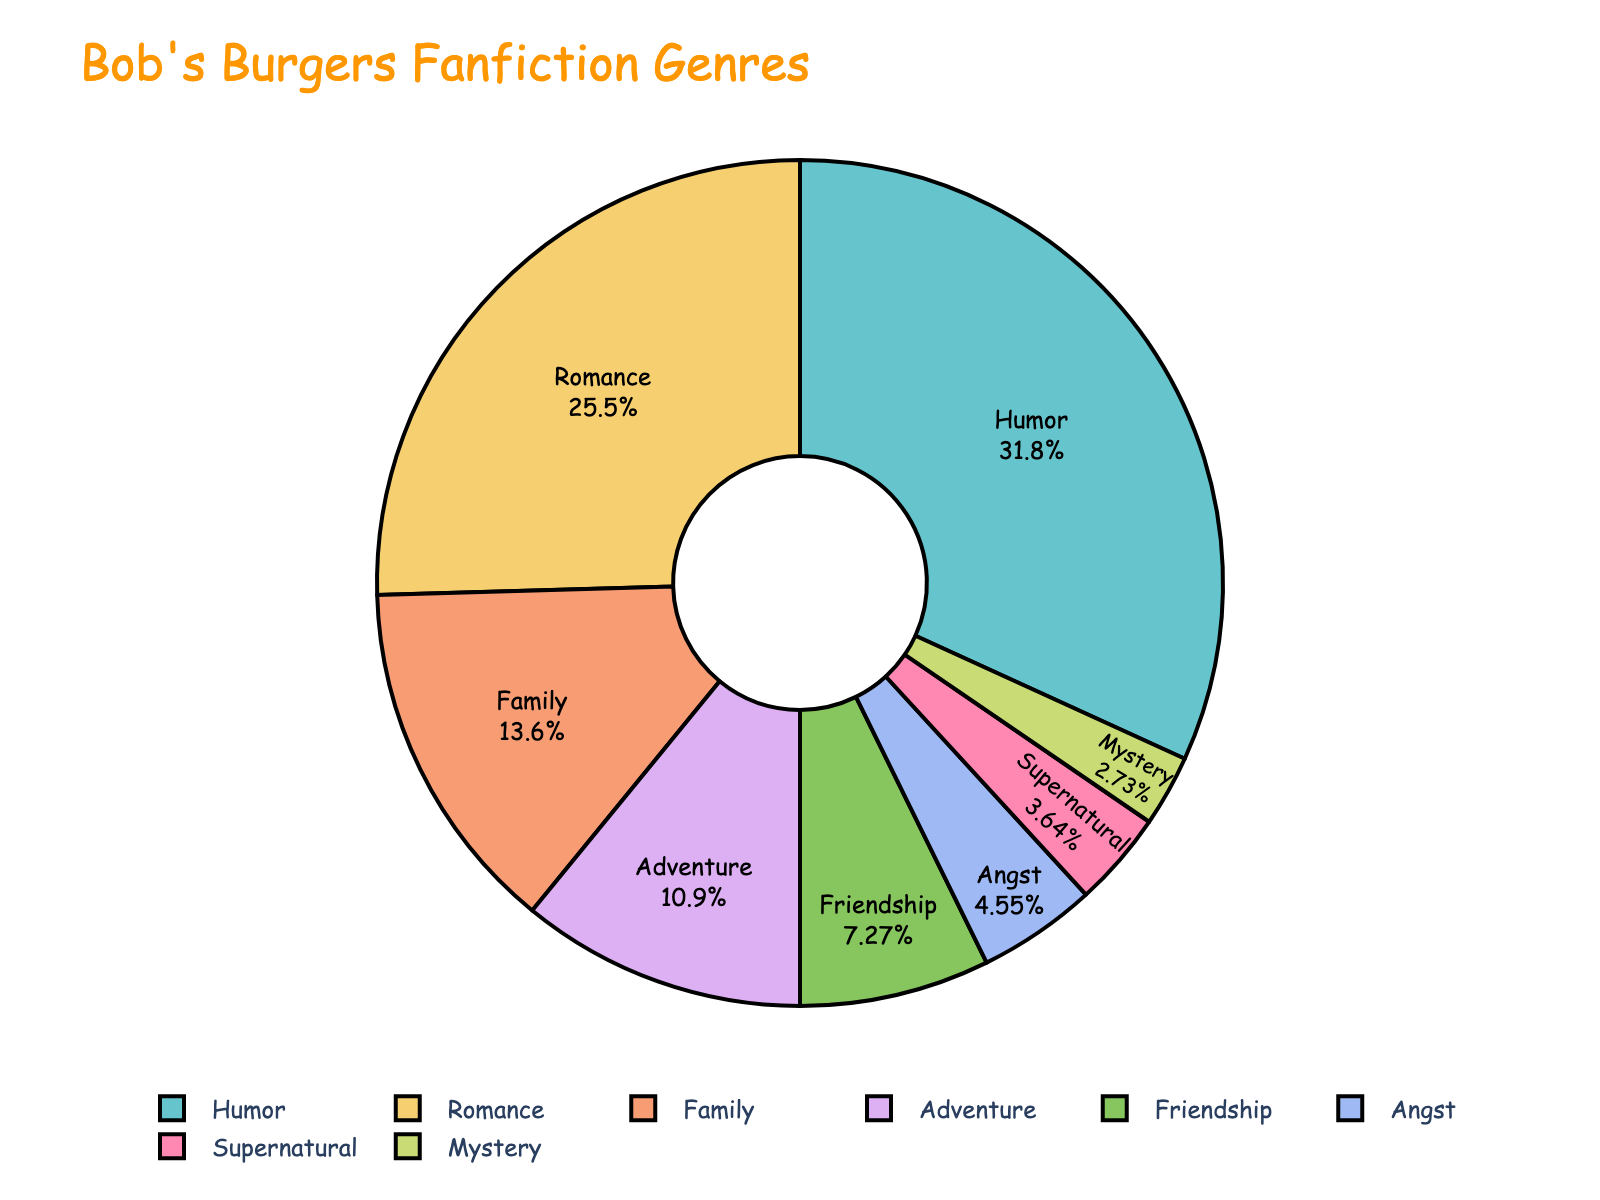What is the most popular genre in Bob's Burgers fanfiction? The pie chart shows the percentage distribution of different genres. The genre with the largest slice is the most popular.
Answer: Humor Which genre has the smallest proportion? By looking at the pie chart, the genre with the smallest slice represents the smallest proportion.
Answer: Mystery How much more popular is Romance compared to Adventure? Romance has 28% and Adventure has 12%. Subtract the proportion of Adventure from Romance: 28% - 12% = 16%.
Answer: 16% What is the total percentage of Adventure, Family, and Friendship genres combined? Add the percentages for Adventure (12%), Family (15%), and Friendship (8%): 12% + 15% + 8% = 35%.
Answer: 35% Is the combined percentage of Angst and Supernatural genres more than that of Family? Sum the percentages of Angst (5%) and Supernatural (4%) and compare with Family (15%): 5% + 4% = 9%, which is less than 15%.
Answer: No Which genre has a proportion closest to 10%? The pie chart shows that the genre with a percentage closest to 10% is Friendship with 8%.
Answer: Friendship How do the proportions of Humor and Romance compare? Humor has 35% and Romance has 28%. Since 35% is greater than 28%, Humor is more popular than Romance.
Answer: Humor is more popular What percentage of fanfiction falls into genres other than Romance, Humor, and Adventure? First, add the percentages of Romance (28%), Humor (35%), and Adventure (12%): 28% + 35% + 12% = 75%. Then subtract from 100%: 100% - 75% = 25%.
Answer: 25% If you combine Family and Friendship genres, does the combined proportion exceed Romance? Sum the percentages for Family (15%) and Friendship (8%): 15% + 8% = 23%. Compare to Romance (28%): 23% < 28%, so it does not exceed.
Answer: No Which three genres combined make up more than 50% of the pie chart? Identify the three largest slices and add their percentages: Humor (35%), Romance (28%), and Family (15%): 35% + 28% + 15% = 78%.
Answer: Humor, Romance, Family 